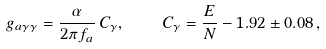<formula> <loc_0><loc_0><loc_500><loc_500>g _ { a \gamma \gamma } = \frac { \alpha } { 2 \pi f _ { a } } \, C _ { \gamma } , \quad C _ { \gamma } = \frac { E } { N } - 1 . 9 2 \pm 0 . 0 8 \, ,</formula> 